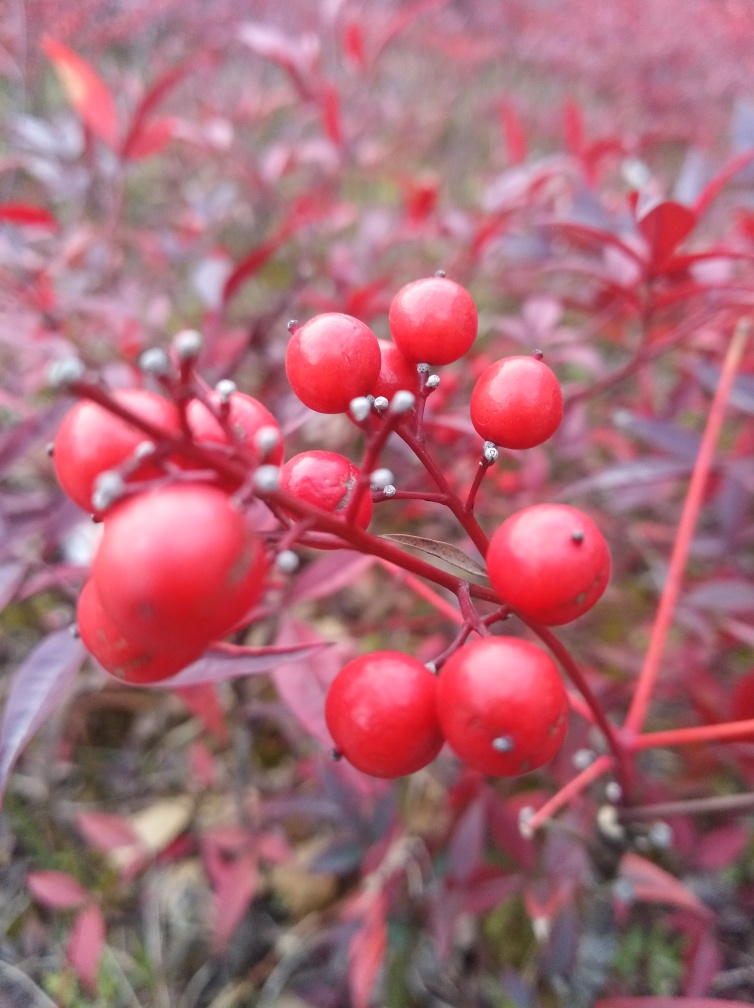Can you tell me more about the plant shown in the image? This plant appears to be a species known for its bright red berries and reddish leaves, which are often associated with various types of deciduous shrubs. These characteristics are typical of plants that add a splash of color to the landscape in fall environments. 